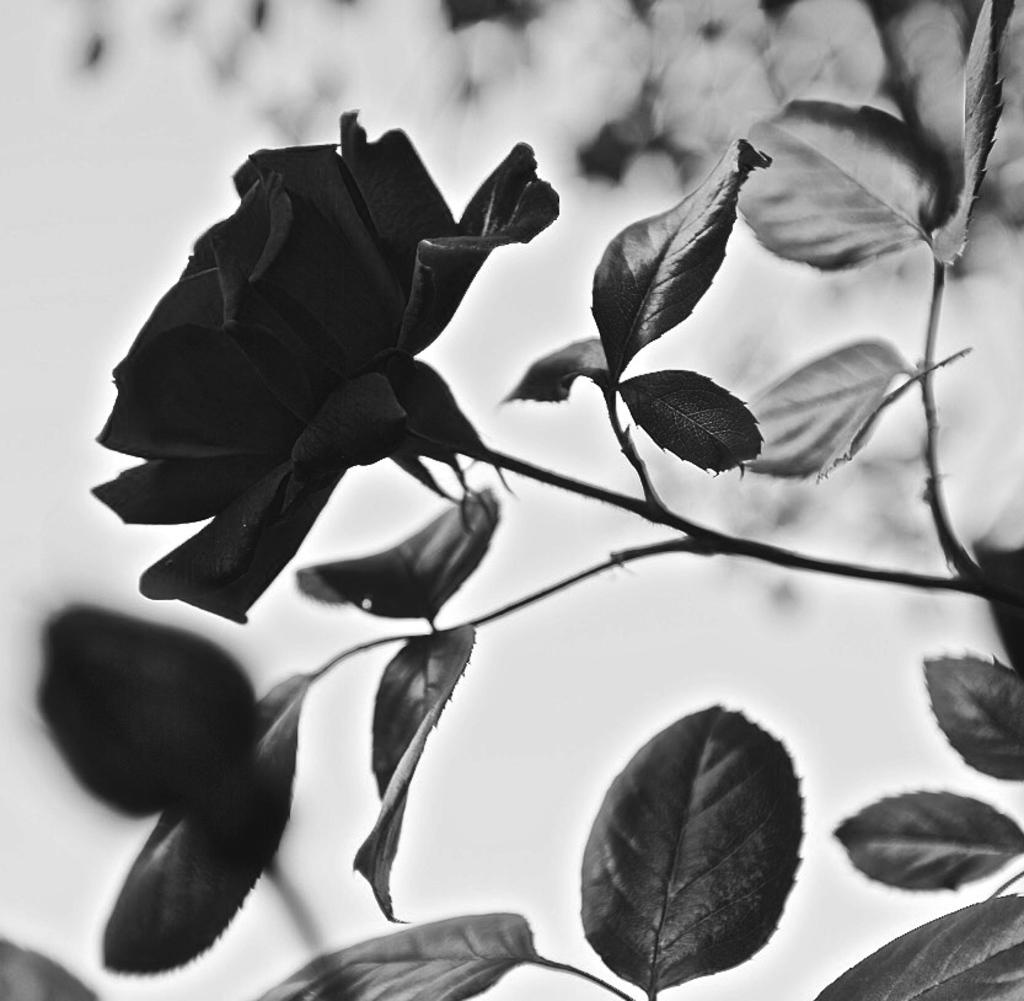What is the color scheme of the image? The image is black and white. What type of plant can be seen in the image? There is a flower and a tree in the image. How would you describe the background of the image? The background is blurry. What type of pipe is visible in the image? There is no pipe present in the image. What answer can be seen written on the tree in the image? There is no answer written on the tree in the image, as it is a natural object and not a surface for writing. 